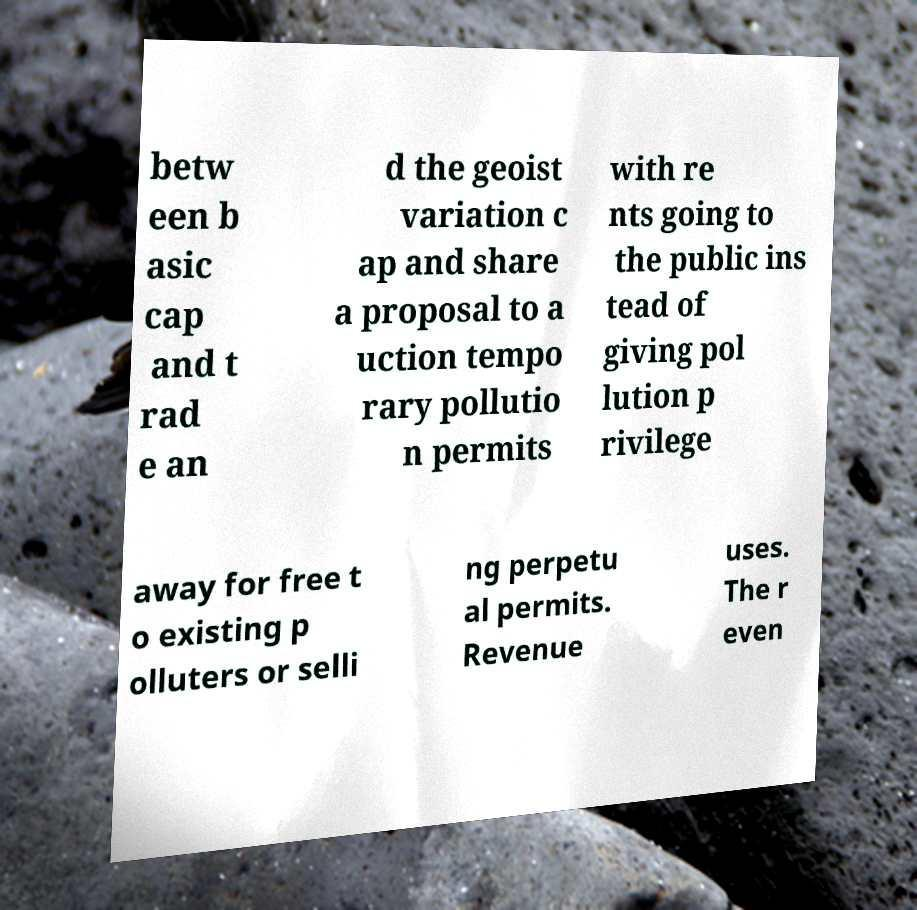Could you extract and type out the text from this image? betw een b asic cap and t rad e an d the geoist variation c ap and share a proposal to a uction tempo rary pollutio n permits with re nts going to the public ins tead of giving pol lution p rivilege away for free t o existing p olluters or selli ng perpetu al permits. Revenue uses. The r even 